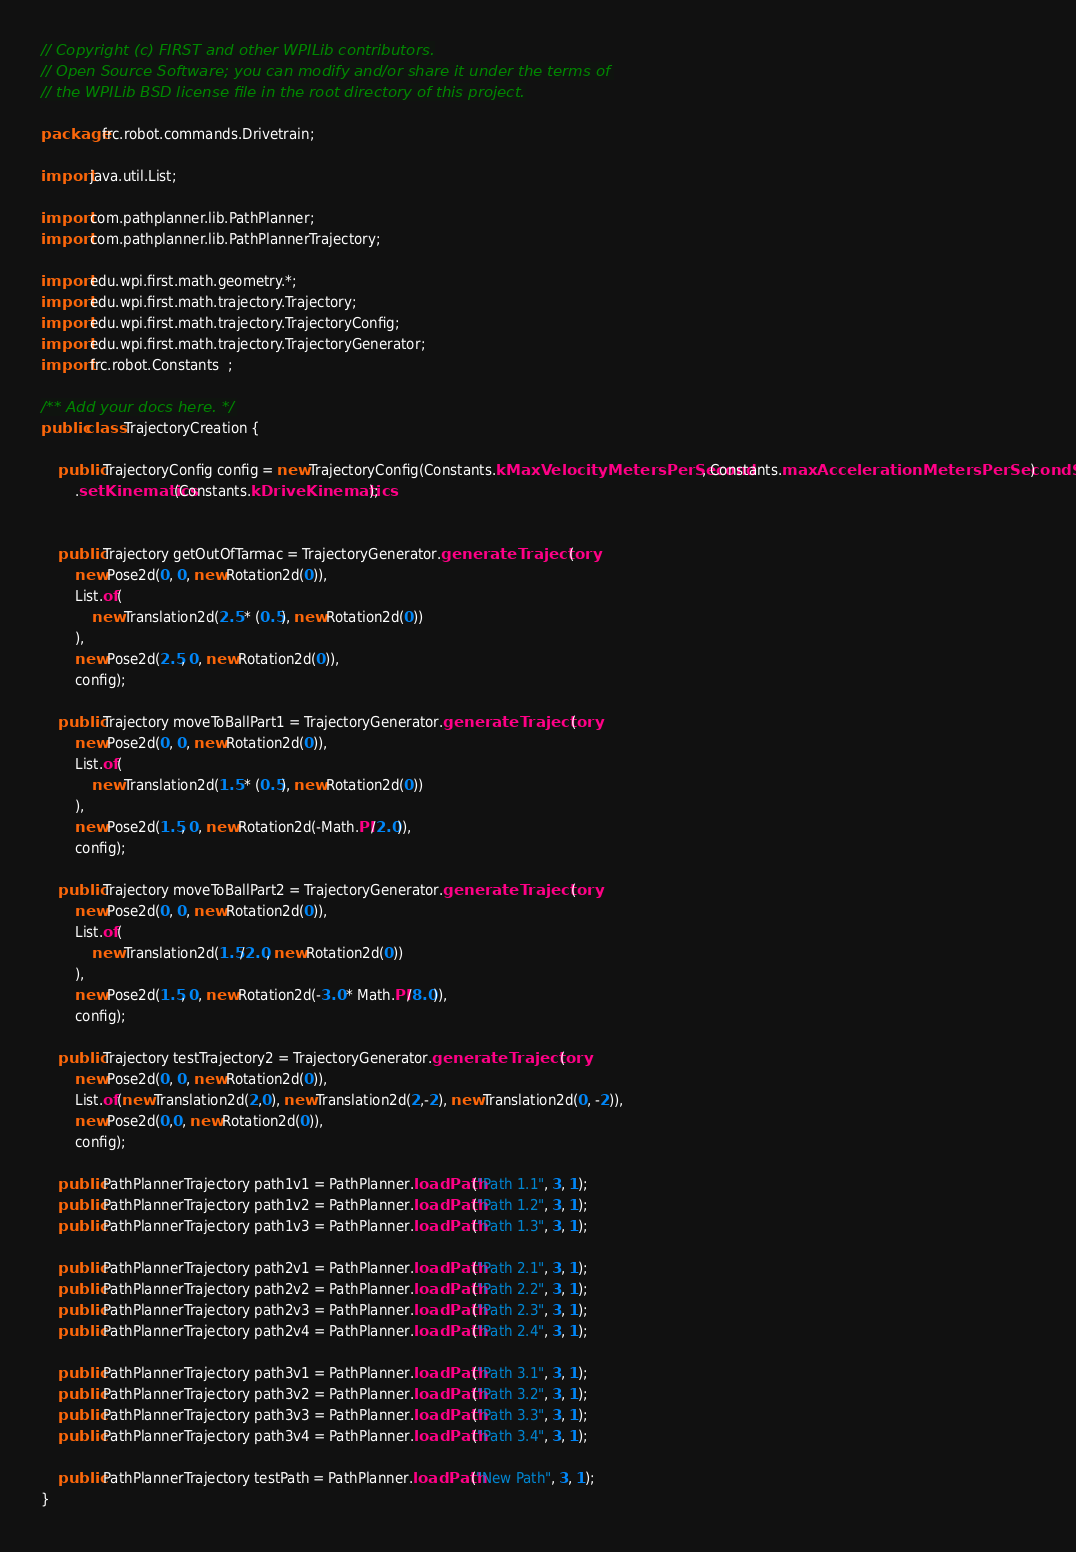<code> <loc_0><loc_0><loc_500><loc_500><_Java_>// Copyright (c) FIRST and other WPILib contributors.
// Open Source Software; you can modify and/or share it under the terms of
// the WPILib BSD license file in the root directory of this project.

package frc.robot.commands.Drivetrain;

import java.util.List;

import com.pathplanner.lib.PathPlanner;
import com.pathplanner.lib.PathPlannerTrajectory;

import edu.wpi.first.math.geometry.*;
import edu.wpi.first.math.trajectory.Trajectory;
import edu.wpi.first.math.trajectory.TrajectoryConfig;
import edu.wpi.first.math.trajectory.TrajectoryGenerator;
import frc.robot.Constants  ;

/** Add your docs here. */
public class TrajectoryCreation {

    public TrajectoryConfig config = new TrajectoryConfig(Constants.kMaxVelocityMetersPerSecond, Constants.maxAccelerationMetersPerSecondSq)
        .setKinematics(Constants.kDriveKinematics);
    
    
    public Trajectory getOutOfTarmac = TrajectoryGenerator.generateTrajectory(
        new Pose2d(0, 0, new Rotation2d(0)), 
        List.of(
            new Translation2d(2.5 * (0.5), new Rotation2d(0))            
        ),
        new Pose2d(2.5, 0, new Rotation2d(0)), 
        config);

    public Trajectory moveToBallPart1 = TrajectoryGenerator.generateTrajectory(
        new Pose2d(0, 0, new Rotation2d(0)), 
        List.of(
            new Translation2d(1.5 * (0.5), new Rotation2d(0))            
        ),
        new Pose2d(1.5, 0, new Rotation2d(-Math.PI/2.0)), 
        config);

    public Trajectory moveToBallPart2 = TrajectoryGenerator.generateTrajectory(
        new Pose2d(0, 0, new Rotation2d(0)), 
        List.of(
            new Translation2d(1.5/2.0, new Rotation2d(0))
        ),
        new Pose2d(1.5, 0, new Rotation2d(-3.0 * Math.PI/8.0)), 
        config);

    public Trajectory testTrajectory2 = TrajectoryGenerator.generateTrajectory(
        new Pose2d(0, 0, new Rotation2d(0)), 
        List.of(new Translation2d(2,0), new Translation2d(2,-2), new Translation2d(0, -2)),
        new Pose2d(0,0, new Rotation2d(0)), 
        config);

    public PathPlannerTrajectory path1v1 = PathPlanner.loadPath("Path 1.1", 3, 1);
    public PathPlannerTrajectory path1v2 = PathPlanner.loadPath("Path 1.2", 3, 1);
    public PathPlannerTrajectory path1v3 = PathPlanner.loadPath("Path 1.3", 3, 1);

    public PathPlannerTrajectory path2v1 = PathPlanner.loadPath("Path 2.1", 3, 1);
    public PathPlannerTrajectory path2v2 = PathPlanner.loadPath("Path 2.2", 3, 1);
    public PathPlannerTrajectory path2v3 = PathPlanner.loadPath("Path 2.3", 3, 1);
    public PathPlannerTrajectory path2v4 = PathPlanner.loadPath("Path 2.4", 3, 1);

    public PathPlannerTrajectory path3v1 = PathPlanner.loadPath("Path 3.1", 3, 1);
    public PathPlannerTrajectory path3v2 = PathPlanner.loadPath("Path 3.2", 3, 1);
    public PathPlannerTrajectory path3v3 = PathPlanner.loadPath("Path 3.3", 3, 1);
    public PathPlannerTrajectory path3v4 = PathPlanner.loadPath("Path 3.4", 3, 1);

    public PathPlannerTrajectory testPath = PathPlanner.loadPath("New Path", 3, 1);
}
</code> 